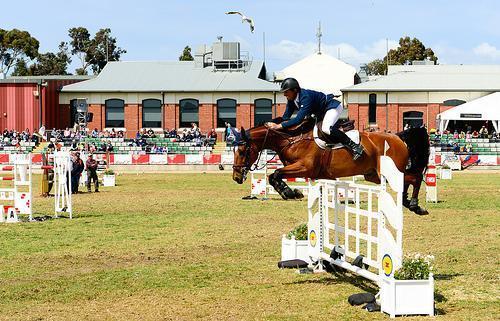How many birds are pictured?
Give a very brief answer. 1. 